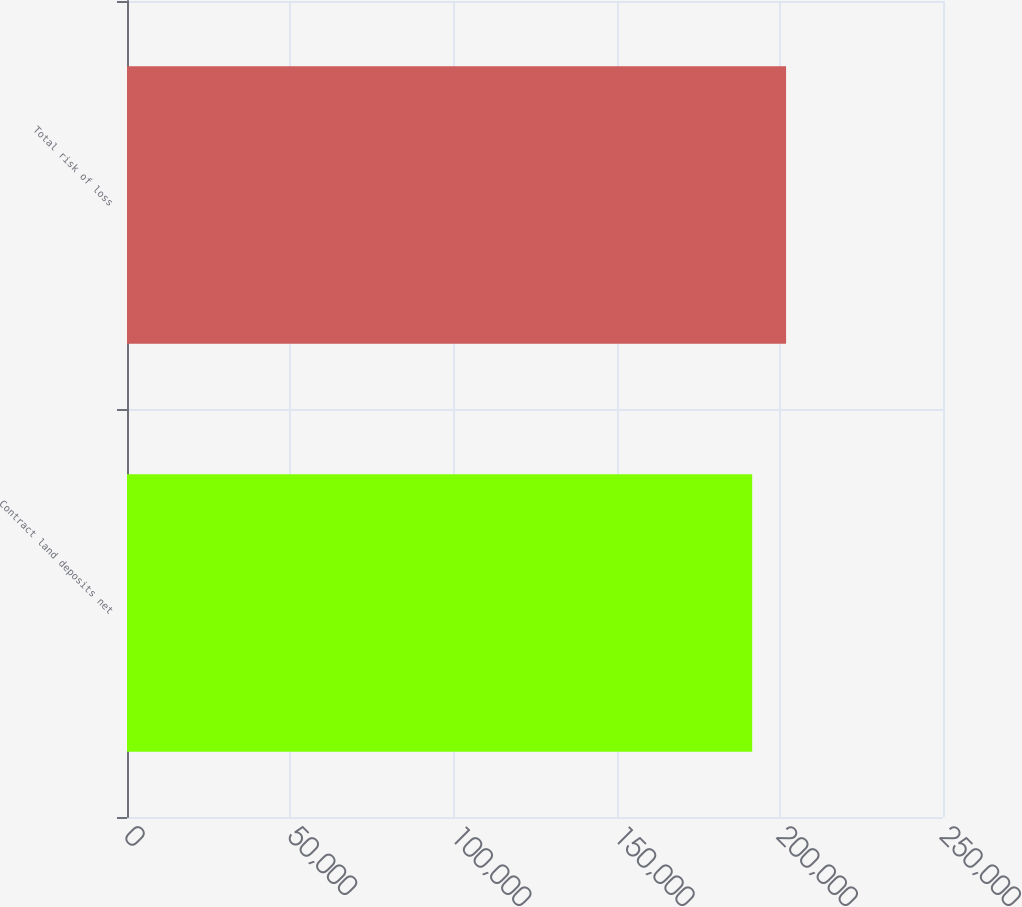<chart> <loc_0><loc_0><loc_500><loc_500><bar_chart><fcel>Contract land deposits net<fcel>Total risk of loss<nl><fcel>191538<fcel>201923<nl></chart> 